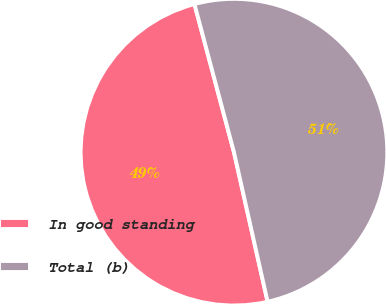<chart> <loc_0><loc_0><loc_500><loc_500><pie_chart><fcel>In good standing<fcel>Total (b)<nl><fcel>49.37%<fcel>50.63%<nl></chart> 